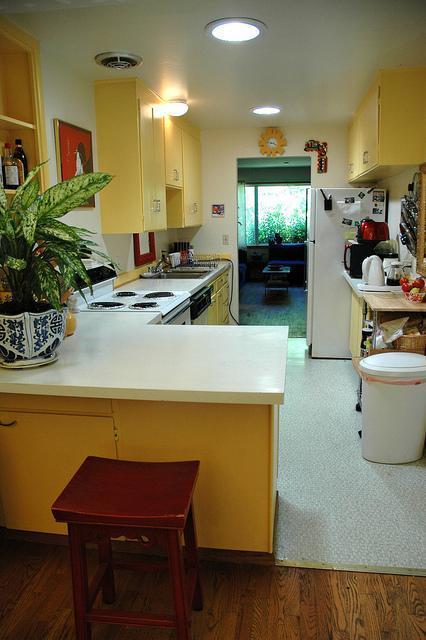How many potted plants are there?
Give a very brief answer. 1. How many people are carrying a skateboard?
Give a very brief answer. 0. 